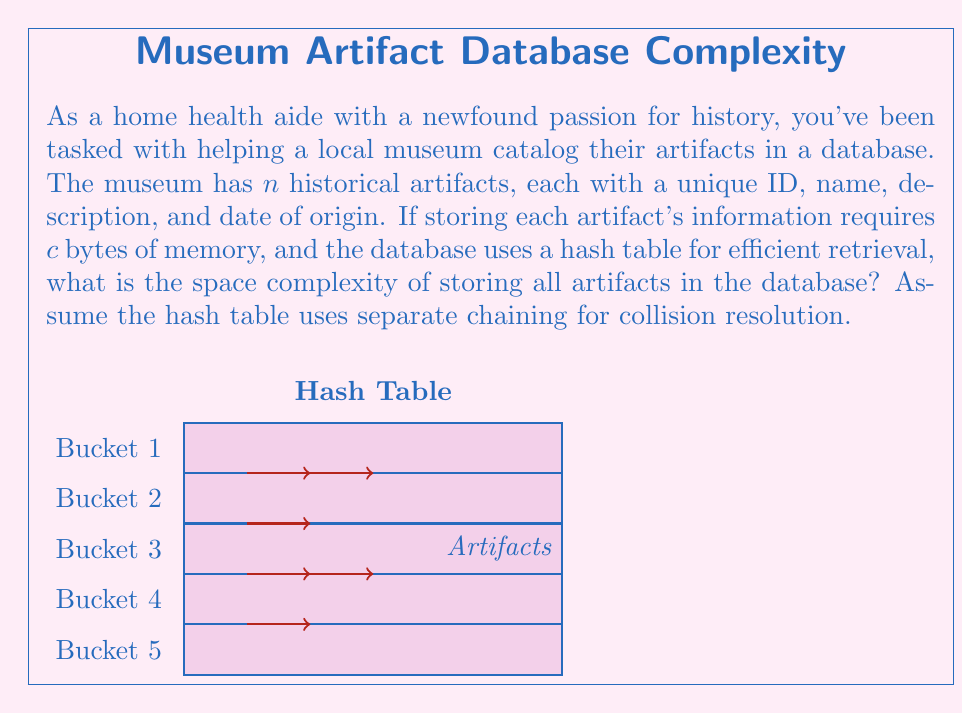Can you solve this math problem? Let's approach this step-by-step:

1) First, we need to consider the space required for storing the artifacts themselves:
   - Each artifact requires $c$ bytes of memory
   - There are $n$ artifacts
   - Total space for artifacts: $n \cdot c$ bytes

2) Now, let's consider the hash table structure:
   - A hash table typically has an array of buckets
   - The number of buckets is usually proportional to the number of items, let's say it's $k \cdot n$, where $k$ is a constant
   - Each bucket contains a pointer to a linked list (for separate chaining)
   - A pointer typically requires 8 bytes on a 64-bit system

3) Space for the hash table structure:
   - Number of buckets: $k \cdot n$
   - Space for bucket array: $8k \cdot n$ bytes (assuming 8-byte pointers)

4) For the linked lists in separate chaining:
   - Each node in the linked list needs to store the artifact data ($c$ bytes) and a pointer to the next node (8 bytes)
   - So each node requires $(c + 8)$ bytes
   - There are $n$ nodes in total (one for each artifact)

5) Total space complexity:
   $$\text{Total Space} = 8k \cdot n + n \cdot (c + 8)$$
   $$= n(8k + c + 8)$$
   $$= n(8k + c + 8)$$

6) In Big O notation, we ignore constant factors and lower-order terms. Both $k$ and $c$ are constants, so we can simplify this to:

   $$O(n)$$

This means the space complexity grows linearly with the number of artifacts.
Answer: $O(n)$ 